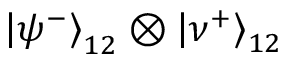<formula> <loc_0><loc_0><loc_500><loc_500>\left | \psi ^ { - } \right \rangle _ { 1 2 } \otimes \left | \nu ^ { + } \right \rangle _ { 1 2 }</formula> 